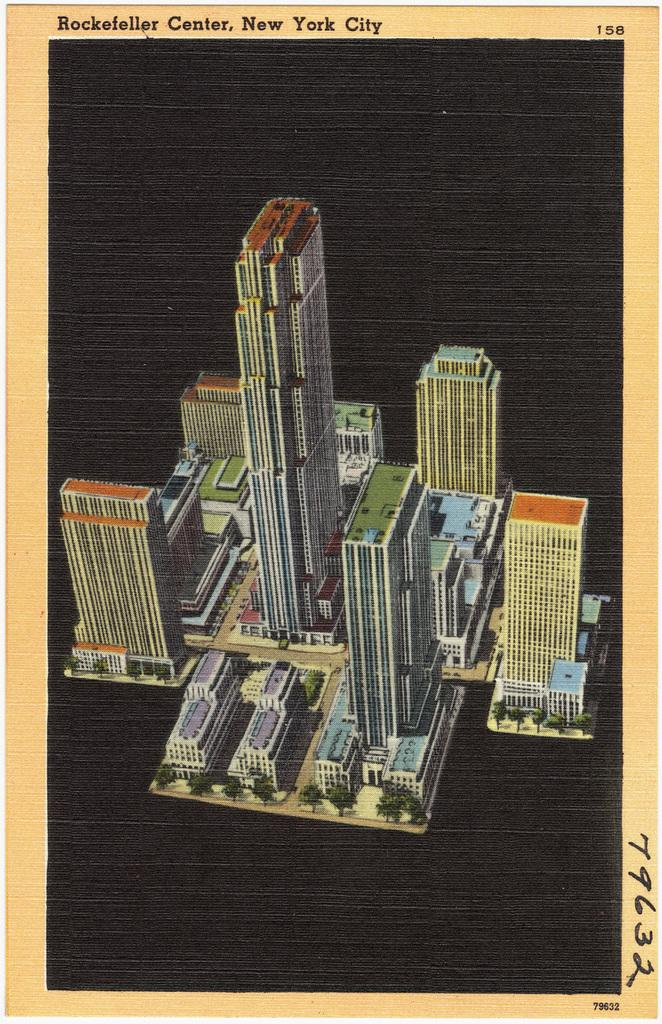What type of structures can be seen in the image? There are buildings in the image. What other natural elements are present in the image? There are trees in the image. What is the color of the background in the image? The background of the image is black. Where can writing be found in the image? There is writing at the top of the image and on the right side of the image. How many brothers are visible in the image? There are no brothers present in the image. Can you see any snakes in the image? There are no snakes present in the image. 